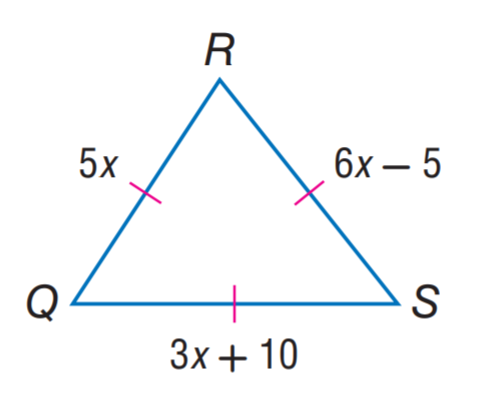Answer the mathemtical geometry problem and directly provide the correct option letter.
Question: Find Q R.
Choices: A: 5 B: 15 C: 20 D: 25 D 